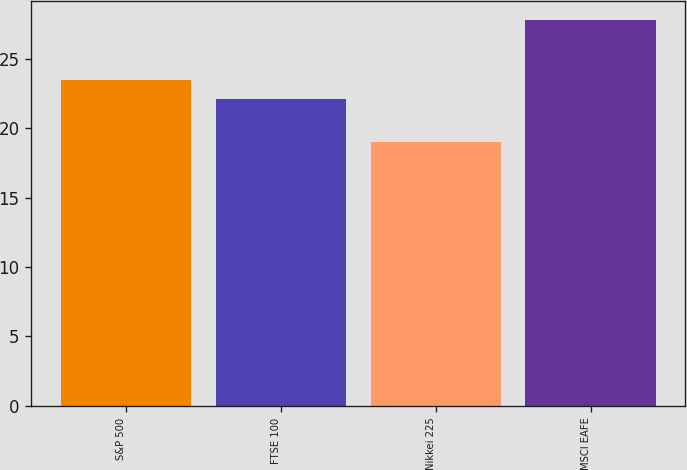<chart> <loc_0><loc_0><loc_500><loc_500><bar_chart><fcel>S&P 500<fcel>FTSE 100<fcel>Nikkei 225<fcel>MSCI EAFE<nl><fcel>23.5<fcel>22.1<fcel>19<fcel>27.8<nl></chart> 